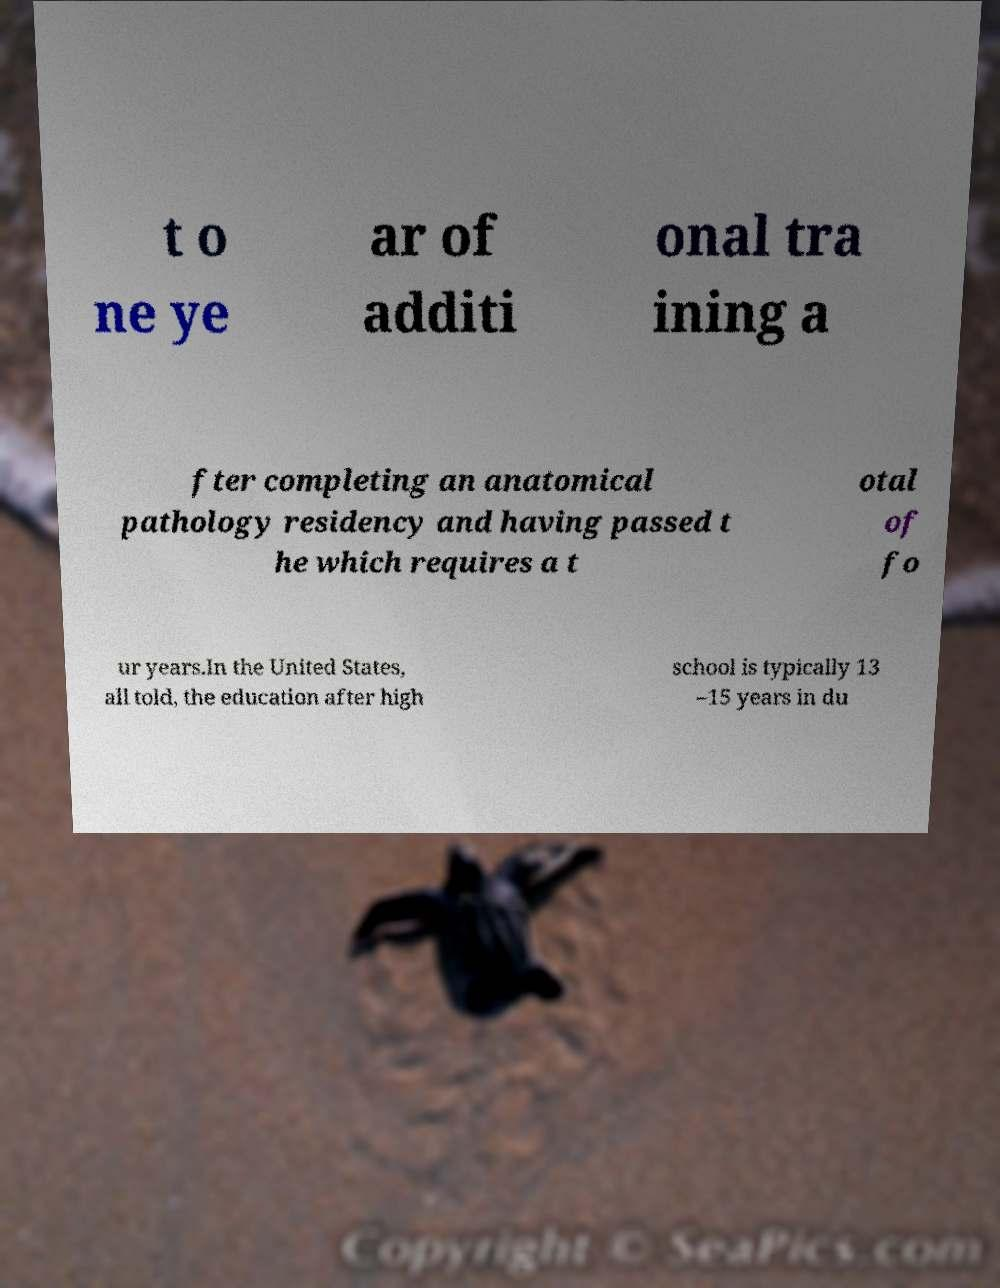Can you accurately transcribe the text from the provided image for me? t o ne ye ar of additi onal tra ining a fter completing an anatomical pathology residency and having passed t he which requires a t otal of fo ur years.In the United States, all told, the education after high school is typically 13 –15 years in du 